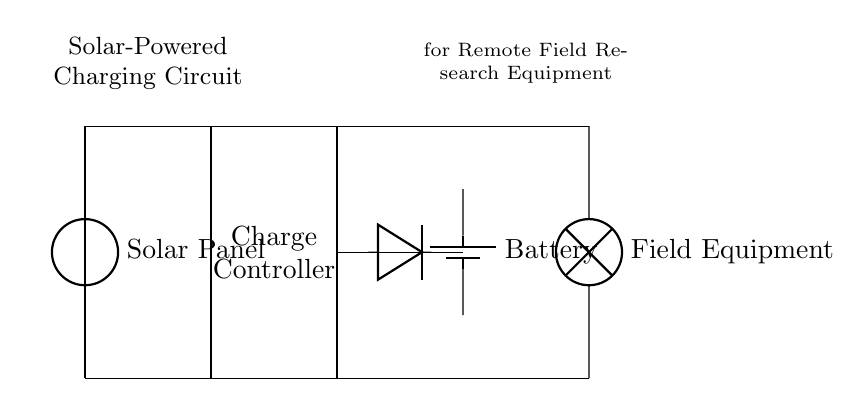What is the main power source in this circuit? The main power source is the solar panel, which is indicated as the voltage source on the left side of the diagram.
Answer: solar panel What component prevents reverse current flow? The component that prevents reverse current is a diode, shown in the circuit, which allows current to flow in one direction only.
Answer: diode How many main components are there in this circuit? There are four main components in the circuit: the solar panel, charge controller, battery, and field equipment, as identified in the drawing.
Answer: four Which component stores energy? The component that stores energy is the battery, which is responsible for holding charge for later use by the field equipment.
Answer: battery What function does the charge controller serve? The charge controller regulates voltage and current from the solar panel to ensure the battery is charged safely and effectively, preventing overcharging and ensuring efficiency.
Answer: regulates charging What is the purpose of including a solar panel in this circuit? The purpose of including a solar panel is to harness solar energy to power the circuit, making it suitable for remote areas without access to traditional power sources.
Answer: harness solar energy 